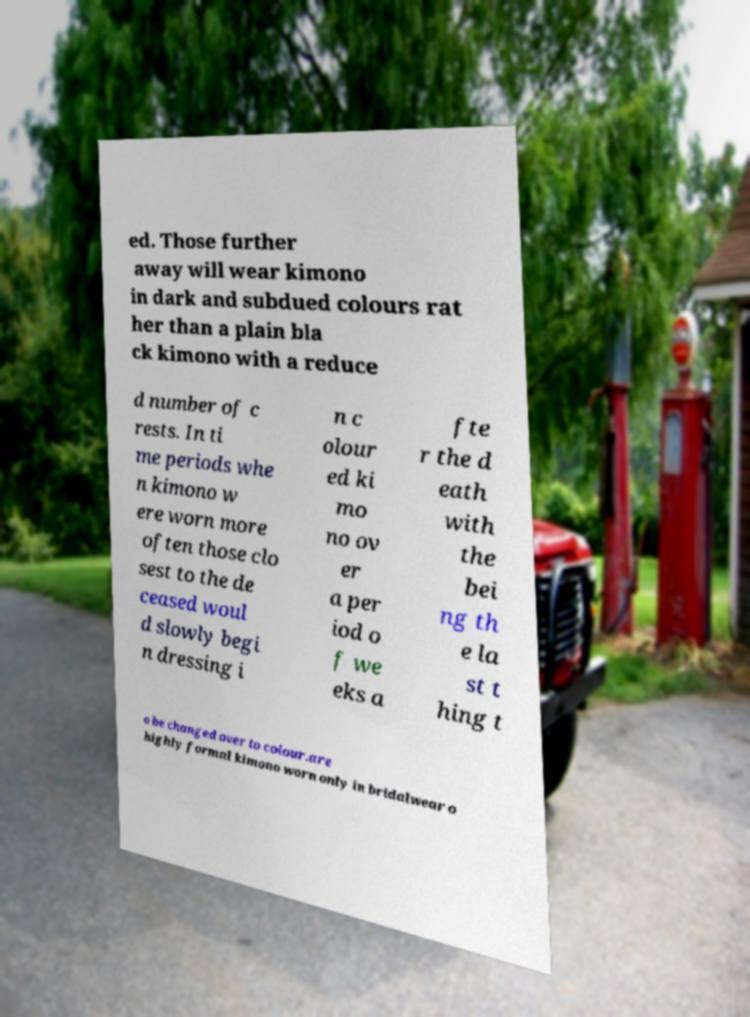Please identify and transcribe the text found in this image. ed. Those further away will wear kimono in dark and subdued colours rat her than a plain bla ck kimono with a reduce d number of c rests. In ti me periods whe n kimono w ere worn more often those clo sest to the de ceased woul d slowly begi n dressing i n c olour ed ki mo no ov er a per iod o f we eks a fte r the d eath with the bei ng th e la st t hing t o be changed over to colour.are highly formal kimono worn only in bridalwear o 